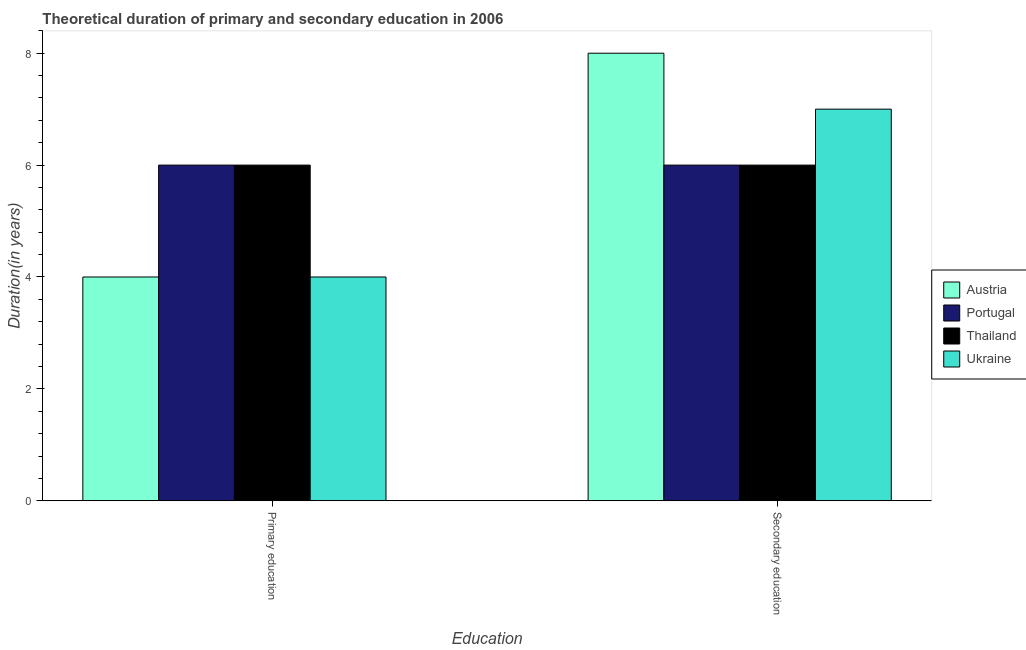How many different coloured bars are there?
Your response must be concise. 4. How many bars are there on the 2nd tick from the left?
Offer a terse response. 4. What is the duration of secondary education in Ukraine?
Your response must be concise. 7. Across all countries, what is the maximum duration of secondary education?
Your answer should be compact. 8. Across all countries, what is the minimum duration of primary education?
Offer a terse response. 4. In which country was the duration of primary education maximum?
Your response must be concise. Portugal. In which country was the duration of secondary education minimum?
Give a very brief answer. Portugal. What is the total duration of primary education in the graph?
Your answer should be very brief. 20. What is the difference between the duration of secondary education in Thailand and the duration of primary education in Ukraine?
Make the answer very short. 2. What is the average duration of primary education per country?
Provide a short and direct response. 5. In how many countries, is the duration of secondary education greater than the average duration of secondary education taken over all countries?
Make the answer very short. 2. What does the 1st bar from the left in Secondary education represents?
Your answer should be very brief. Austria. What does the 3rd bar from the right in Secondary education represents?
Keep it short and to the point. Portugal. Are all the bars in the graph horizontal?
Give a very brief answer. No. How many countries are there in the graph?
Ensure brevity in your answer.  4. Does the graph contain grids?
Your answer should be very brief. No. How many legend labels are there?
Your response must be concise. 4. How are the legend labels stacked?
Provide a short and direct response. Vertical. What is the title of the graph?
Provide a short and direct response. Theoretical duration of primary and secondary education in 2006. What is the label or title of the X-axis?
Keep it short and to the point. Education. What is the label or title of the Y-axis?
Give a very brief answer. Duration(in years). What is the Duration(in years) in Austria in Primary education?
Provide a short and direct response. 4. What is the Duration(in years) of Thailand in Primary education?
Your answer should be very brief. 6. What is the Duration(in years) in Thailand in Secondary education?
Keep it short and to the point. 6. What is the Duration(in years) of Ukraine in Secondary education?
Offer a terse response. 7. Across all Education, what is the maximum Duration(in years) in Austria?
Make the answer very short. 8. Across all Education, what is the maximum Duration(in years) in Portugal?
Provide a succinct answer. 6. Across all Education, what is the maximum Duration(in years) of Thailand?
Ensure brevity in your answer.  6. Across all Education, what is the maximum Duration(in years) in Ukraine?
Ensure brevity in your answer.  7. Across all Education, what is the minimum Duration(in years) in Austria?
Your response must be concise. 4. Across all Education, what is the minimum Duration(in years) in Portugal?
Your response must be concise. 6. Across all Education, what is the minimum Duration(in years) in Thailand?
Give a very brief answer. 6. What is the total Duration(in years) in Ukraine in the graph?
Provide a succinct answer. 11. What is the difference between the Duration(in years) of Austria in Primary education and that in Secondary education?
Your answer should be compact. -4. What is the difference between the Duration(in years) in Portugal in Primary education and that in Secondary education?
Offer a terse response. 0. What is the difference between the Duration(in years) of Thailand in Primary education and that in Secondary education?
Your answer should be compact. 0. What is the difference between the Duration(in years) of Austria in Primary education and the Duration(in years) of Thailand in Secondary education?
Offer a very short reply. -2. What is the difference between the Duration(in years) in Thailand in Primary education and the Duration(in years) in Ukraine in Secondary education?
Offer a very short reply. -1. What is the average Duration(in years) of Portugal per Education?
Your answer should be compact. 6. What is the average Duration(in years) in Thailand per Education?
Your answer should be very brief. 6. What is the average Duration(in years) of Ukraine per Education?
Offer a terse response. 5.5. What is the difference between the Duration(in years) of Austria and Duration(in years) of Portugal in Primary education?
Offer a very short reply. -2. What is the difference between the Duration(in years) of Austria and Duration(in years) of Portugal in Secondary education?
Keep it short and to the point. 2. What is the difference between the Duration(in years) in Austria and Duration(in years) in Thailand in Secondary education?
Your answer should be compact. 2. What is the difference between the Duration(in years) in Austria and Duration(in years) in Ukraine in Secondary education?
Give a very brief answer. 1. What is the difference between the Duration(in years) in Portugal and Duration(in years) in Thailand in Secondary education?
Keep it short and to the point. 0. What is the difference between the Duration(in years) of Portugal and Duration(in years) of Ukraine in Secondary education?
Give a very brief answer. -1. What is the difference between the Duration(in years) in Thailand and Duration(in years) in Ukraine in Secondary education?
Your answer should be compact. -1. What is the ratio of the Duration(in years) in Austria in Primary education to that in Secondary education?
Provide a short and direct response. 0.5. What is the ratio of the Duration(in years) in Portugal in Primary education to that in Secondary education?
Make the answer very short. 1. What is the ratio of the Duration(in years) of Thailand in Primary education to that in Secondary education?
Make the answer very short. 1. What is the ratio of the Duration(in years) in Ukraine in Primary education to that in Secondary education?
Keep it short and to the point. 0.57. What is the difference between the highest and the second highest Duration(in years) in Ukraine?
Make the answer very short. 3. What is the difference between the highest and the lowest Duration(in years) in Austria?
Your answer should be very brief. 4. What is the difference between the highest and the lowest Duration(in years) of Portugal?
Your response must be concise. 0. What is the difference between the highest and the lowest Duration(in years) in Thailand?
Provide a short and direct response. 0. 